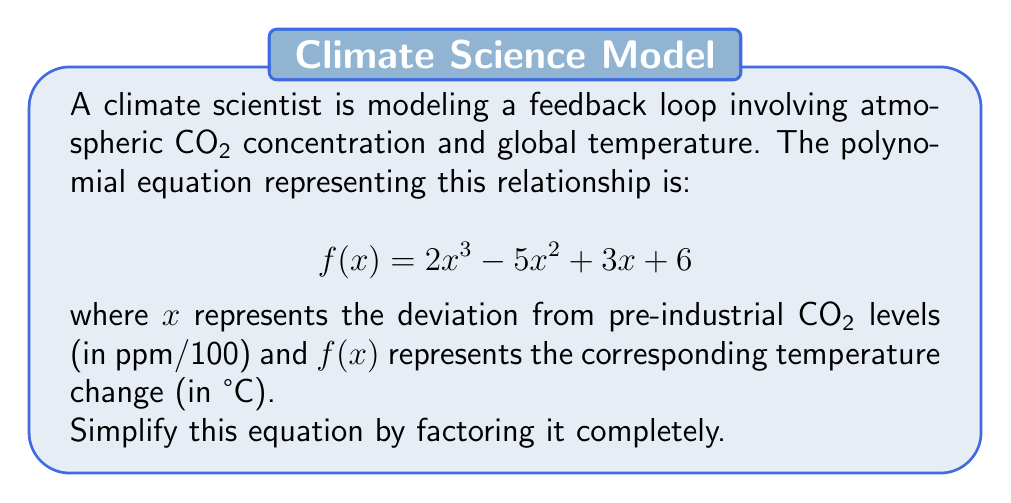What is the answer to this math problem? To factor this polynomial completely, we'll follow these steps:

1) First, check if there's a greatest common factor (GCF):
   There's no common factor for all terms, so we move on.

2) This is a cubic equation. Let's check if there's a rational root using the rational root theorem.
   Possible rational roots: ±1, ±2, ±3, ±6

3) Testing these values, we find that $f(-1) = 0$
   So, $(x+1)$ is a factor.

4) Divide $f(x)$ by $(x+1)$ using polynomial long division:

   $$\frac{2x^3 - 5x^2 + 3x + 6}{x+1} = 2x^2 - 7x + 10$$

5) The quotient $2x^2 - 7x + 10$ is a quadratic that we can factor:
   
   $2x^2 - 7x + 10 = (2x-5)(x-2)$

6) Combining all factors:

   $$f(x) = (x+1)(2x-5)(x-2)$$

This factorization reveals the critical points in the climate feedback loop: 
- When $x = -1$ (a decrease in CO2), 
- When $x = 2.5$ (a significant increase in CO2), and 
- When $x = 2$ (another increase point).

These points could represent important thresholds in the climate system where behavior changes dramatically.
Answer: $f(x) = (x+1)(2x-5)(x-2)$ 